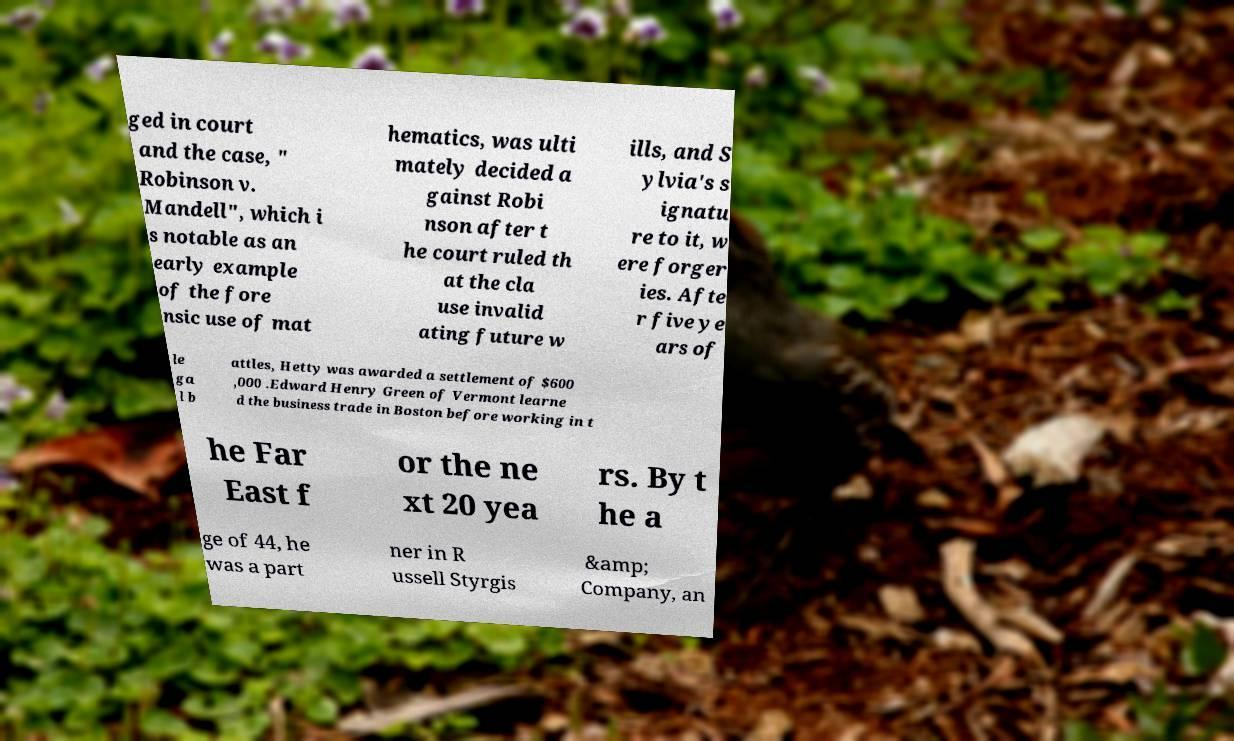For documentation purposes, I need the text within this image transcribed. Could you provide that? ged in court and the case, " Robinson v. Mandell", which i s notable as an early example of the fore nsic use of mat hematics, was ulti mately decided a gainst Robi nson after t he court ruled th at the cla use invalid ating future w ills, and S ylvia's s ignatu re to it, w ere forger ies. Afte r five ye ars of le ga l b attles, Hetty was awarded a settlement of $600 ,000 .Edward Henry Green of Vermont learne d the business trade in Boston before working in t he Far East f or the ne xt 20 yea rs. By t he a ge of 44, he was a part ner in R ussell Styrgis &amp; Company, an 